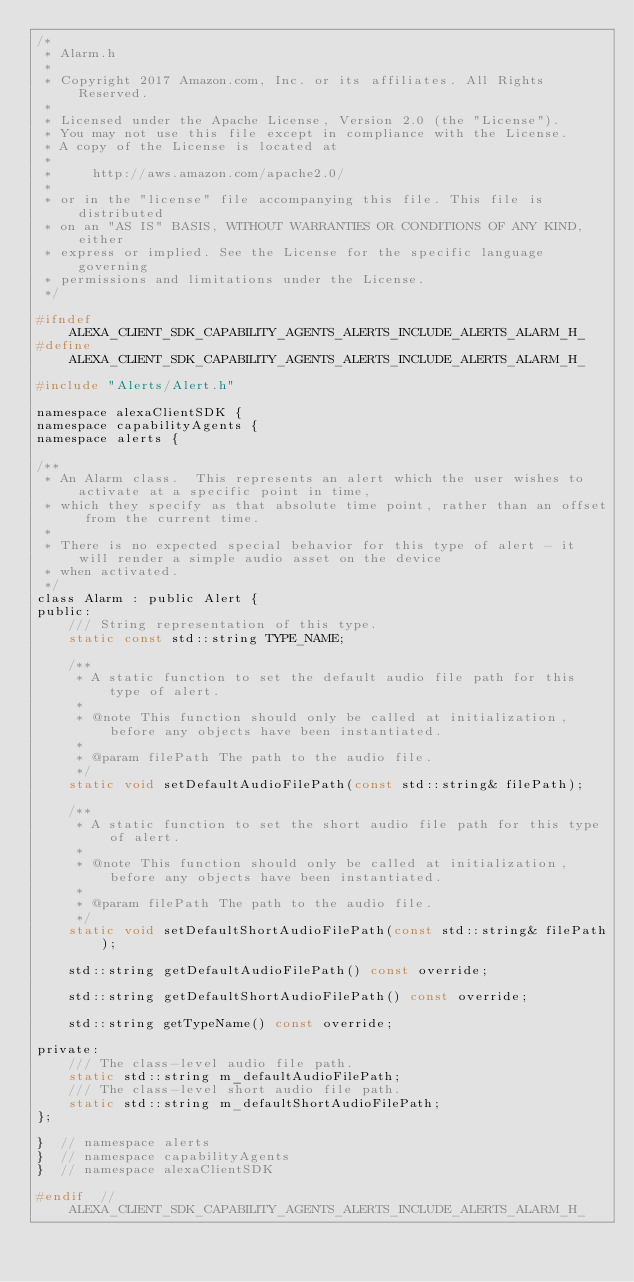<code> <loc_0><loc_0><loc_500><loc_500><_C_>/*
 * Alarm.h
 *
 * Copyright 2017 Amazon.com, Inc. or its affiliates. All Rights Reserved.
 *
 * Licensed under the Apache License, Version 2.0 (the "License").
 * You may not use this file except in compliance with the License.
 * A copy of the License is located at
 *
 *     http://aws.amazon.com/apache2.0/
 *
 * or in the "license" file accompanying this file. This file is distributed
 * on an "AS IS" BASIS, WITHOUT WARRANTIES OR CONDITIONS OF ANY KIND, either
 * express or implied. See the License for the specific language governing
 * permissions and limitations under the License.
 */

#ifndef ALEXA_CLIENT_SDK_CAPABILITY_AGENTS_ALERTS_INCLUDE_ALERTS_ALARM_H_
#define ALEXA_CLIENT_SDK_CAPABILITY_AGENTS_ALERTS_INCLUDE_ALERTS_ALARM_H_

#include "Alerts/Alert.h"

namespace alexaClientSDK {
namespace capabilityAgents {
namespace alerts {

/**
 * An Alarm class.  This represents an alert which the user wishes to activate at a specific point in time,
 * which they specify as that absolute time point, rather than an offset from the current time.
 *
 * There is no expected special behavior for this type of alert - it will render a simple audio asset on the device
 * when activated.
 */
class Alarm : public Alert {
public:
    /// String representation of this type.
    static const std::string TYPE_NAME;

    /**
     * A static function to set the default audio file path for this type of alert.
     *
     * @note This function should only be called at initialization, before any objects have been instantiated.
     *
     * @param filePath The path to the audio file.
     */
    static void setDefaultAudioFilePath(const std::string& filePath);

    /**
     * A static function to set the short audio file path for this type of alert.
     *
     * @note This function should only be called at initialization, before any objects have been instantiated.
     *
     * @param filePath The path to the audio file.
     */
    static void setDefaultShortAudioFilePath(const std::string& filePath);

    std::string getDefaultAudioFilePath() const override;

    std::string getDefaultShortAudioFilePath() const override;

    std::string getTypeName() const override;

private:
    /// The class-level audio file path.
    static std::string m_defaultAudioFilePath;
    /// The class-level short audio file path.
    static std::string m_defaultShortAudioFilePath;
};

}  // namespace alerts
}  // namespace capabilityAgents
}  // namespace alexaClientSDK

#endif  // ALEXA_CLIENT_SDK_CAPABILITY_AGENTS_ALERTS_INCLUDE_ALERTS_ALARM_H_</code> 